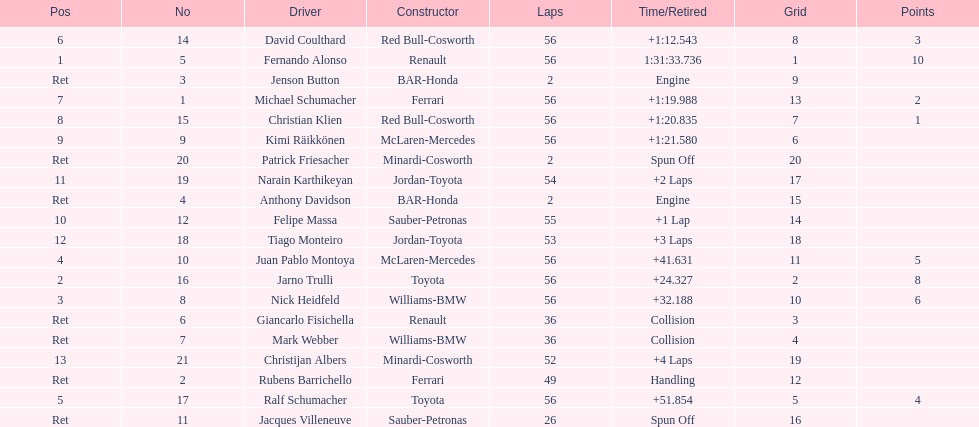What driver finished first? Fernando Alonso. 